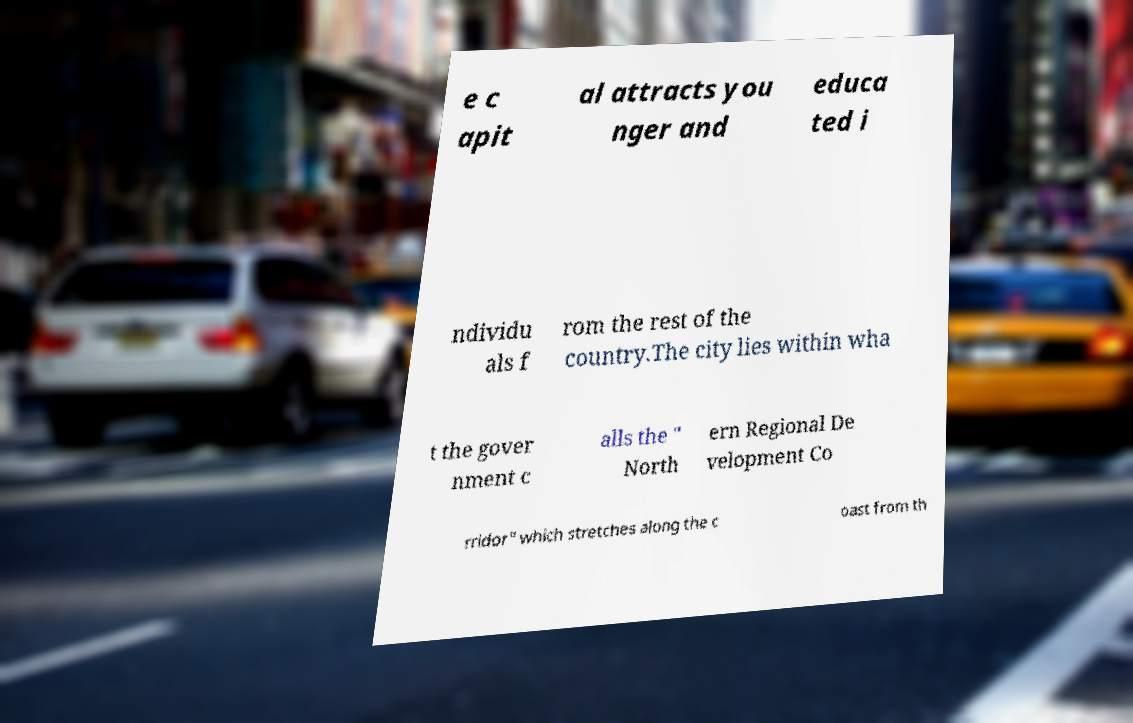I need the written content from this picture converted into text. Can you do that? e c apit al attracts you nger and educa ted i ndividu als f rom the rest of the country.The city lies within wha t the gover nment c alls the " North ern Regional De velopment Co rridor" which stretches along the c oast from th 